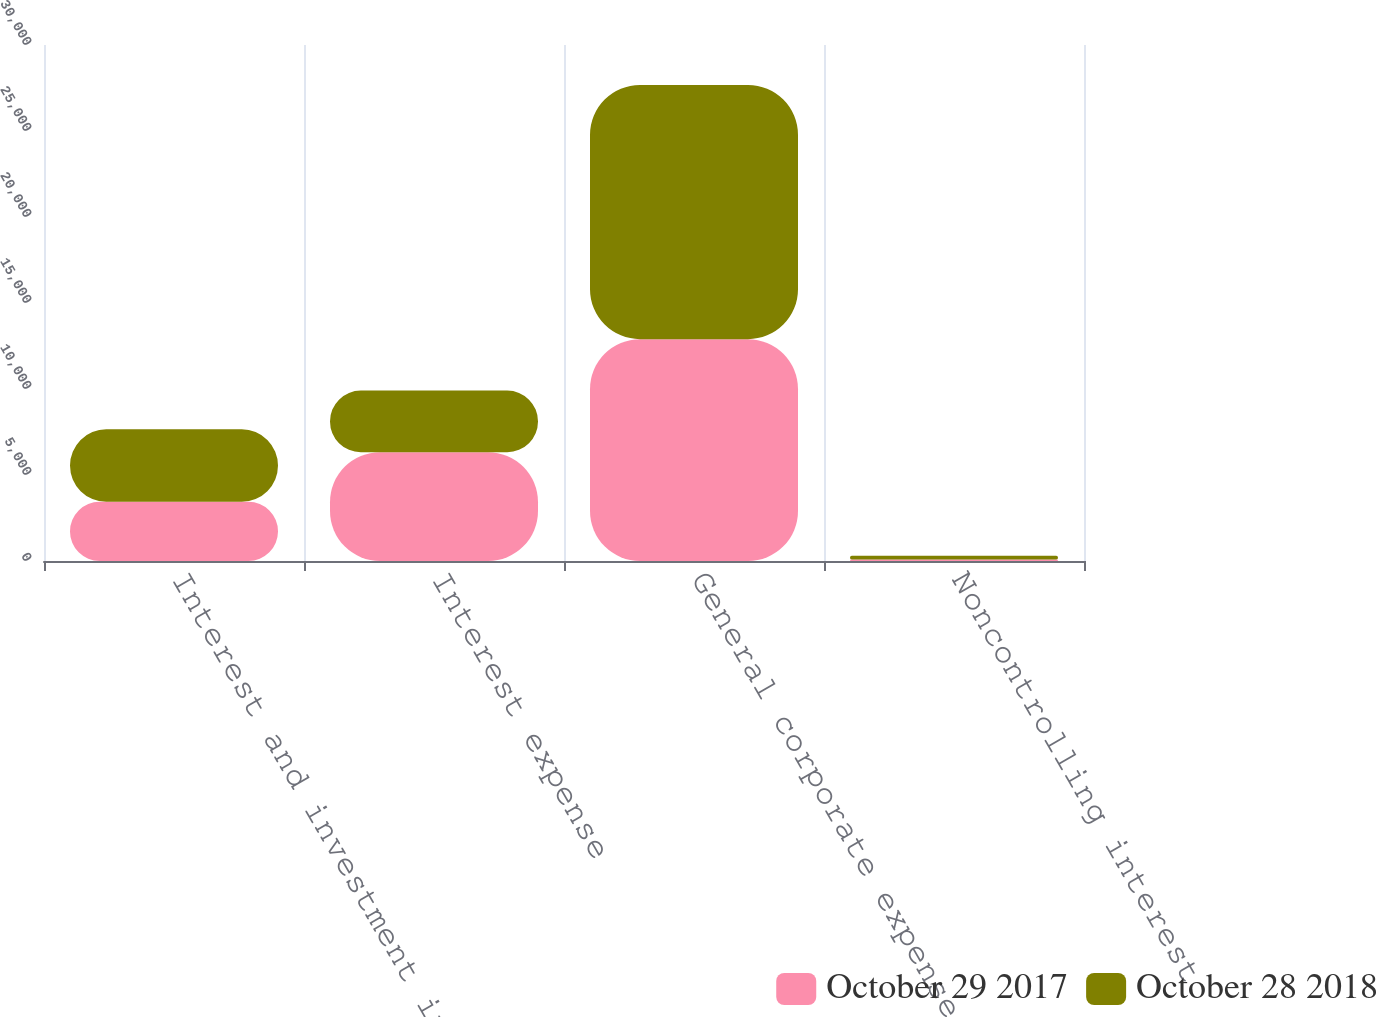Convert chart. <chart><loc_0><loc_0><loc_500><loc_500><stacked_bar_chart><ecel><fcel>Interest and investment income<fcel>Interest expense<fcel>General corporate expense<fcel>Noncontrolling interest<nl><fcel>October 29 2017<fcel>3439<fcel>6329<fcel>12897<fcel>90<nl><fcel>October 28 2018<fcel>4216<fcel>3577<fcel>14783<fcel>209<nl></chart> 